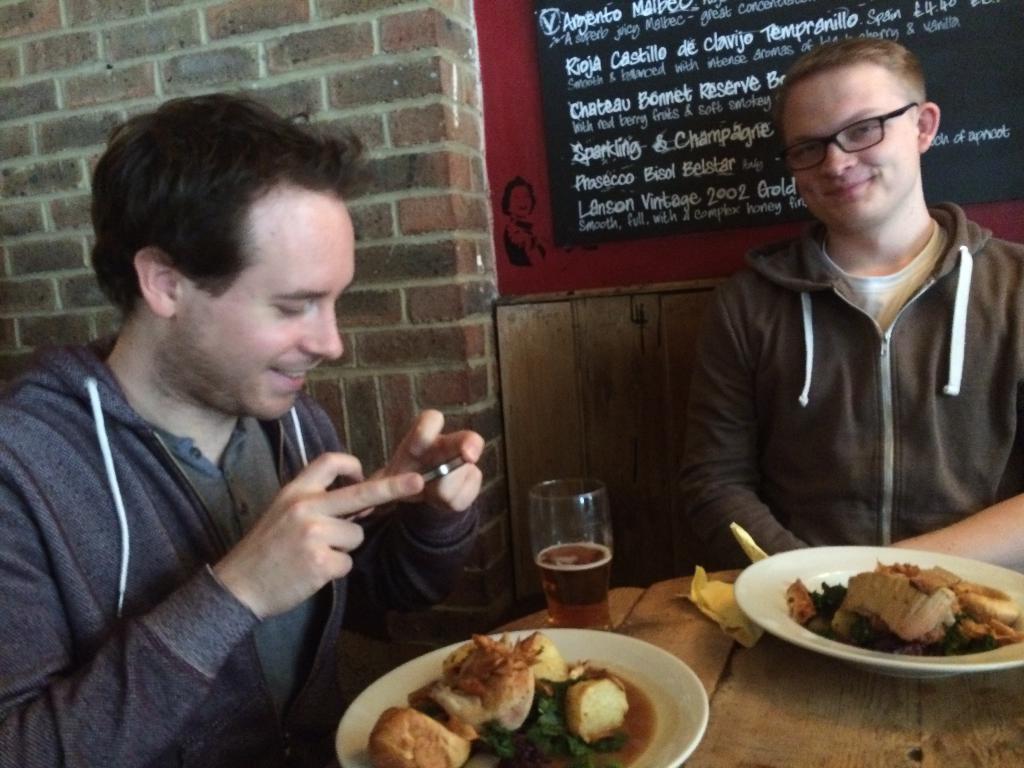Could you give a brief overview of what you see in this image? In this picture there is a man who is wearing hoodie and t-shirt. He is holding a mobile phone. He is sitting near to the table. On the table there are two plates, paper and wine glass. In that plates I can see some food items. On the right there is a man who is wearing hoodie, t-shirt and spectacles. He is sitting on the chair. Both of them are smiling. At the back there is a black board on the red wall. In the top left corner there is a brick wall. 